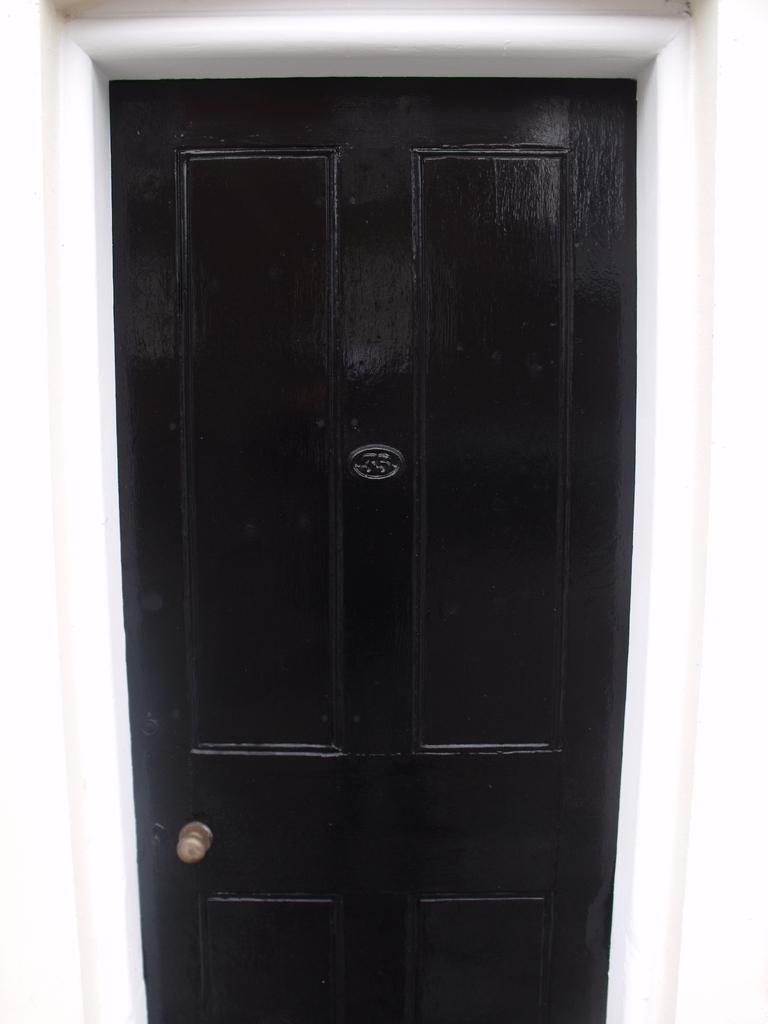What color is the door in the image? The door in the image is black. What feature is present on the door for opening and closing it? The door has a handle. What color can be seen in the image besides the black door? There is a white color visible in the image. What type of gun is being taxed in the image? There is no gun or tax-related information present in the image. 